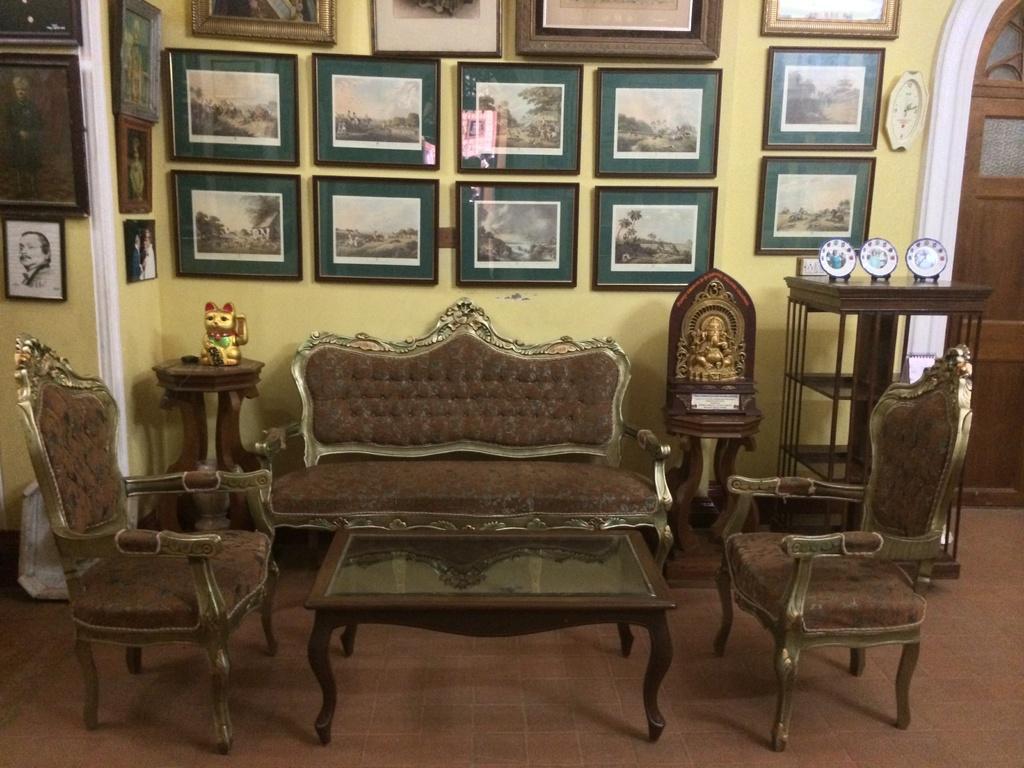Please provide a concise description of this image. This image is inside the room where a sofa set, table, statues are placed on the floor. There are many photo frames attached to the wall. 